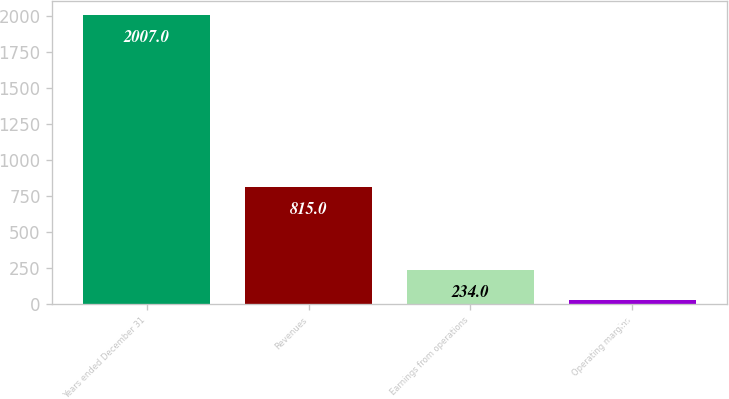<chart> <loc_0><loc_0><loc_500><loc_500><bar_chart><fcel>Years ended December 31<fcel>Revenues<fcel>Earnings from operations<fcel>Operating margins<nl><fcel>2007<fcel>815<fcel>234<fcel>29<nl></chart> 